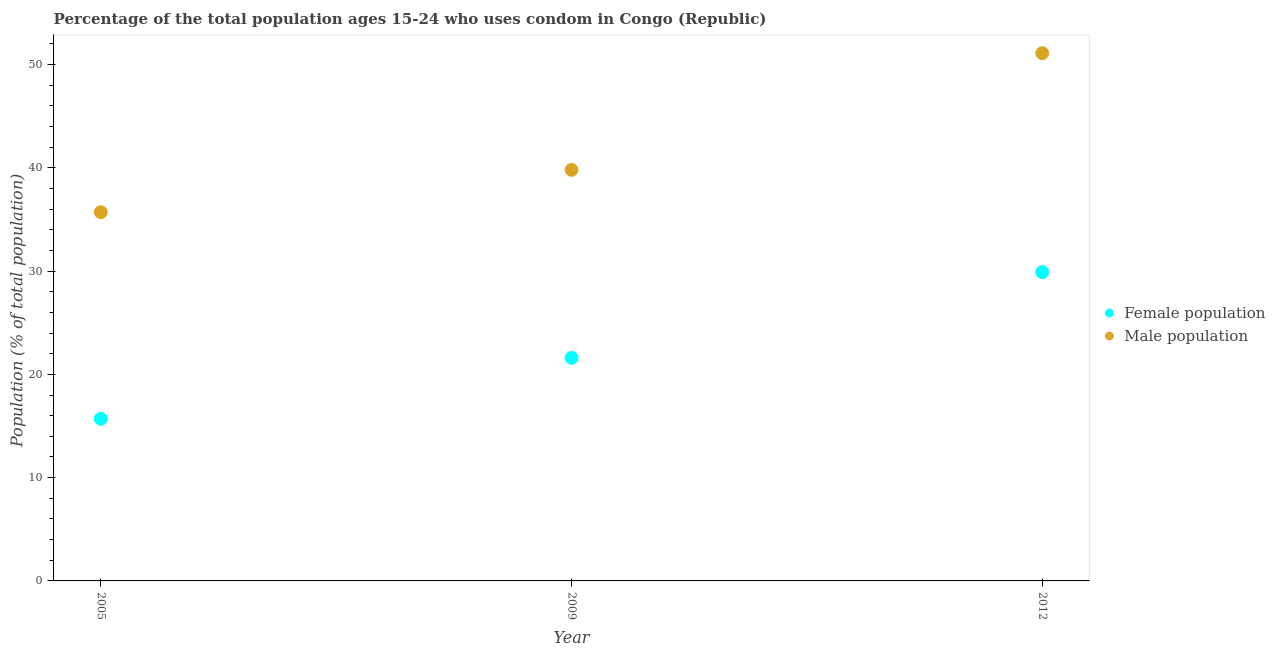What is the female population in 2009?
Make the answer very short. 21.6. Across all years, what is the maximum female population?
Your response must be concise. 29.9. Across all years, what is the minimum male population?
Offer a very short reply. 35.7. What is the total male population in the graph?
Make the answer very short. 126.6. What is the difference between the female population in 2005 and that in 2009?
Provide a short and direct response. -5.9. What is the difference between the female population in 2012 and the male population in 2009?
Offer a terse response. -9.9. What is the average male population per year?
Make the answer very short. 42.2. In the year 2009, what is the difference between the male population and female population?
Ensure brevity in your answer.  18.2. What is the ratio of the female population in 2005 to that in 2012?
Provide a short and direct response. 0.53. Is the male population in 2005 less than that in 2012?
Offer a very short reply. Yes. Is the difference between the male population in 2005 and 2012 greater than the difference between the female population in 2005 and 2012?
Provide a succinct answer. No. What is the difference between the highest and the second highest female population?
Provide a succinct answer. 8.3. What is the difference between the highest and the lowest female population?
Provide a short and direct response. 14.2. Is the male population strictly greater than the female population over the years?
Offer a very short reply. Yes. Is the female population strictly less than the male population over the years?
Offer a very short reply. Yes. How many years are there in the graph?
Offer a terse response. 3. What is the difference between two consecutive major ticks on the Y-axis?
Ensure brevity in your answer.  10. Are the values on the major ticks of Y-axis written in scientific E-notation?
Provide a succinct answer. No. Does the graph contain grids?
Provide a short and direct response. No. Where does the legend appear in the graph?
Your answer should be compact. Center right. What is the title of the graph?
Make the answer very short. Percentage of the total population ages 15-24 who uses condom in Congo (Republic). Does "Investment" appear as one of the legend labels in the graph?
Offer a terse response. No. What is the label or title of the X-axis?
Provide a succinct answer. Year. What is the label or title of the Y-axis?
Offer a very short reply. Population (% of total population) . What is the Population (% of total population)  in Female population in 2005?
Provide a succinct answer. 15.7. What is the Population (% of total population)  of Male population in 2005?
Ensure brevity in your answer.  35.7. What is the Population (% of total population)  of Female population in 2009?
Your answer should be very brief. 21.6. What is the Population (% of total population)  of Male population in 2009?
Provide a short and direct response. 39.8. What is the Population (% of total population)  in Female population in 2012?
Your answer should be very brief. 29.9. What is the Population (% of total population)  in Male population in 2012?
Offer a terse response. 51.1. Across all years, what is the maximum Population (% of total population)  of Female population?
Ensure brevity in your answer.  29.9. Across all years, what is the maximum Population (% of total population)  in Male population?
Offer a terse response. 51.1. Across all years, what is the minimum Population (% of total population)  in Male population?
Provide a short and direct response. 35.7. What is the total Population (% of total population)  of Female population in the graph?
Provide a succinct answer. 67.2. What is the total Population (% of total population)  of Male population in the graph?
Your answer should be compact. 126.6. What is the difference between the Population (% of total population)  in Female population in 2005 and that in 2009?
Keep it short and to the point. -5.9. What is the difference between the Population (% of total population)  in Male population in 2005 and that in 2009?
Your answer should be very brief. -4.1. What is the difference between the Population (% of total population)  in Female population in 2005 and that in 2012?
Give a very brief answer. -14.2. What is the difference between the Population (% of total population)  in Male population in 2005 and that in 2012?
Provide a succinct answer. -15.4. What is the difference between the Population (% of total population)  in Male population in 2009 and that in 2012?
Your answer should be very brief. -11.3. What is the difference between the Population (% of total population)  of Female population in 2005 and the Population (% of total population)  of Male population in 2009?
Offer a terse response. -24.1. What is the difference between the Population (% of total population)  in Female population in 2005 and the Population (% of total population)  in Male population in 2012?
Provide a succinct answer. -35.4. What is the difference between the Population (% of total population)  in Female population in 2009 and the Population (% of total population)  in Male population in 2012?
Ensure brevity in your answer.  -29.5. What is the average Population (% of total population)  in Female population per year?
Your answer should be very brief. 22.4. What is the average Population (% of total population)  of Male population per year?
Offer a terse response. 42.2. In the year 2005, what is the difference between the Population (% of total population)  in Female population and Population (% of total population)  in Male population?
Offer a very short reply. -20. In the year 2009, what is the difference between the Population (% of total population)  of Female population and Population (% of total population)  of Male population?
Your answer should be very brief. -18.2. In the year 2012, what is the difference between the Population (% of total population)  of Female population and Population (% of total population)  of Male population?
Your answer should be compact. -21.2. What is the ratio of the Population (% of total population)  of Female population in 2005 to that in 2009?
Give a very brief answer. 0.73. What is the ratio of the Population (% of total population)  of Male population in 2005 to that in 2009?
Keep it short and to the point. 0.9. What is the ratio of the Population (% of total population)  of Female population in 2005 to that in 2012?
Offer a very short reply. 0.53. What is the ratio of the Population (% of total population)  of Male population in 2005 to that in 2012?
Your response must be concise. 0.7. What is the ratio of the Population (% of total population)  in Female population in 2009 to that in 2012?
Make the answer very short. 0.72. What is the ratio of the Population (% of total population)  of Male population in 2009 to that in 2012?
Ensure brevity in your answer.  0.78. What is the difference between the highest and the lowest Population (% of total population)  of Female population?
Keep it short and to the point. 14.2. What is the difference between the highest and the lowest Population (% of total population)  in Male population?
Provide a short and direct response. 15.4. 